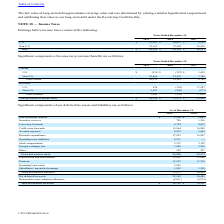From Cts Corporation's financial document, Which years does the table provide information for significant components of the company's deferred tax assets and liabilities? The document shows two values: 2019 and 2018. From the document: "2019 2018 2017 2019 2018 2017..." Also, What were the inventory reserves in 2019? According to the financial document, 708 (in thousands). The relevant text states: "Inventory reserves 708 1,236..." Also, What was the Stock compensation in 2018? According to the financial document, 2,142 (in thousands). The relevant text states: "Stock compensation 2,232 2,142..." Additionally, Which years did Depreciation and amortization exceed $10,000 thousand? The document shows two values: 2019 and 2018. From the document: "2019 2018 2017 2019 2018 2017..." Also, can you calculate: What was the change in Research expenditures between 2018 and 2019? Based on the calculation: 17,953-16,847, the result is 1106 (in thousands). This is based on the information: "Research expenditures 17,953 16,847 Research expenditures 17,953 16,847..." The key data points involved are: 16,847, 17,953. Also, can you calculate: What was the percentage change in the Gross deferred tax assets between 2018 and 2019? To answer this question, I need to perform calculations using the financial data. The calculation is: (56,040-50,979)/50,979, which equals 9.93 (percentage). This is based on the information: "Gross deferred tax assets 56,040 50,979 Gross deferred tax assets 56,040 50,979..." The key data points involved are: 50,979, 56,040. 